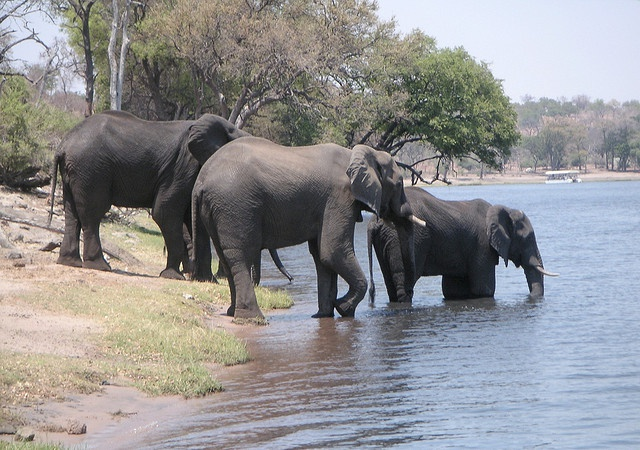Describe the objects in this image and their specific colors. I can see elephant in gray, black, and darkgray tones, elephant in gray and black tones, elephant in gray, black, lavender, and darkgray tones, and boat in gray, lightgray, and darkgray tones in this image. 